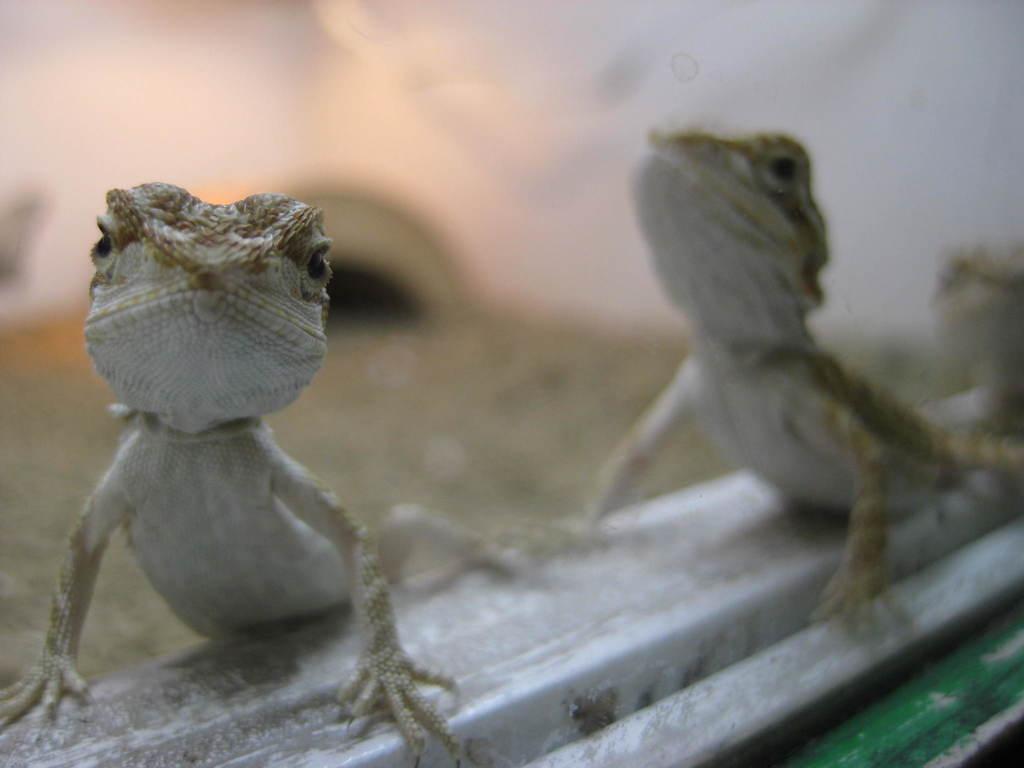In one or two sentences, can you explain what this image depicts? In the picture I can see lizards. The background of the image is blurred. 